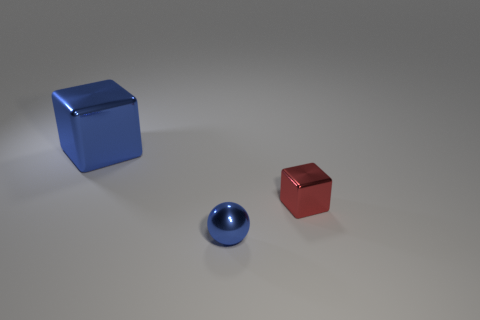Add 1 red objects. How many objects exist? 4 Subtract all spheres. How many objects are left? 2 Add 3 big red cylinders. How many big red cylinders exist? 3 Subtract 1 blue blocks. How many objects are left? 2 Subtract all big blue things. Subtract all red metallic spheres. How many objects are left? 2 Add 1 blue spheres. How many blue spheres are left? 2 